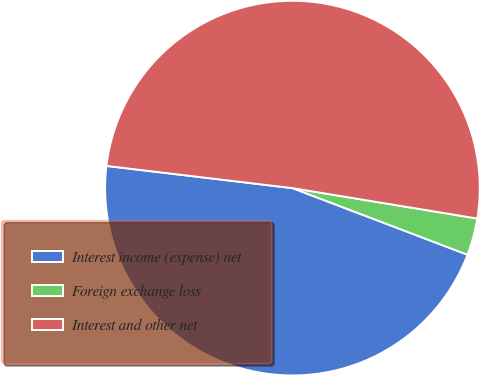Convert chart. <chart><loc_0><loc_0><loc_500><loc_500><pie_chart><fcel>Interest income (expense) net<fcel>Foreign exchange loss<fcel>Interest and other net<nl><fcel>46.11%<fcel>3.19%<fcel>50.71%<nl></chart> 